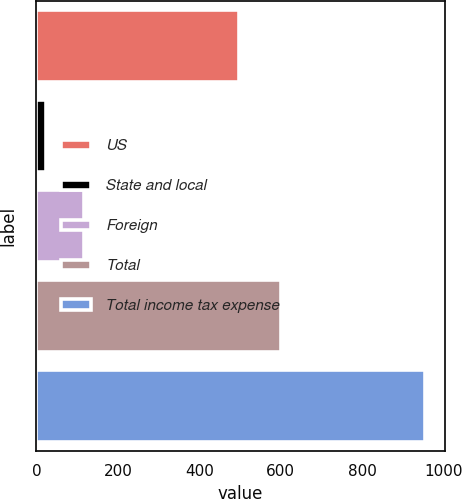<chart> <loc_0><loc_0><loc_500><loc_500><bar_chart><fcel>US<fcel>State and local<fcel>Foreign<fcel>Total<fcel>Total income tax expense<nl><fcel>497<fcel>23<fcel>116.2<fcel>601<fcel>955<nl></chart> 